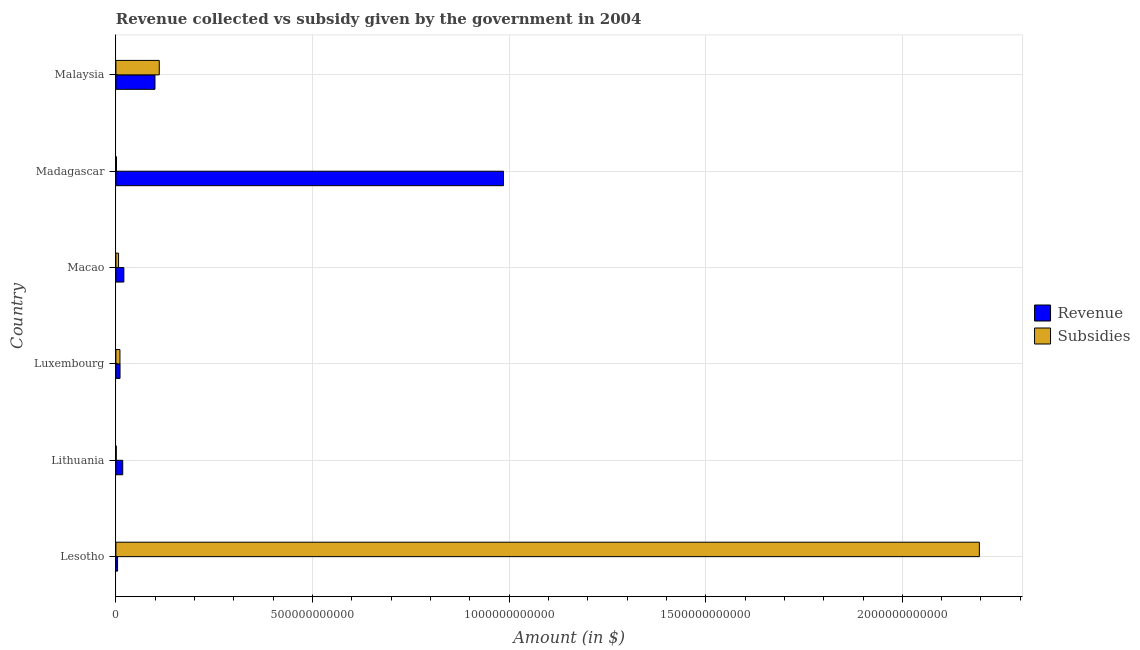Are the number of bars on each tick of the Y-axis equal?
Your answer should be compact. Yes. How many bars are there on the 2nd tick from the top?
Offer a terse response. 2. What is the label of the 3rd group of bars from the top?
Provide a short and direct response. Macao. What is the amount of revenue collected in Malaysia?
Keep it short and to the point. 9.94e+1. Across all countries, what is the maximum amount of subsidies given?
Offer a very short reply. 2.20e+12. Across all countries, what is the minimum amount of revenue collected?
Provide a short and direct response. 4.25e+09. In which country was the amount of revenue collected maximum?
Offer a very short reply. Madagascar. In which country was the amount of subsidies given minimum?
Provide a succinct answer. Lithuania. What is the total amount of revenue collected in the graph?
Your answer should be very brief. 1.14e+12. What is the difference between the amount of revenue collected in Lesotho and that in Madagascar?
Offer a very short reply. -9.81e+11. What is the difference between the amount of subsidies given in Luxembourg and the amount of revenue collected in Macao?
Your answer should be compact. -9.94e+09. What is the average amount of revenue collected per country?
Keep it short and to the point. 1.90e+11. What is the difference between the amount of subsidies given and amount of revenue collected in Malaysia?
Your response must be concise. 1.09e+1. What is the ratio of the amount of subsidies given in Lithuania to that in Malaysia?
Offer a terse response. 0.01. Is the amount of revenue collected in Lesotho less than that in Malaysia?
Your response must be concise. Yes. Is the difference between the amount of revenue collected in Lithuania and Madagascar greater than the difference between the amount of subsidies given in Lithuania and Madagascar?
Your response must be concise. No. What is the difference between the highest and the second highest amount of subsidies given?
Your response must be concise. 2.09e+12. What is the difference between the highest and the lowest amount of subsidies given?
Your response must be concise. 2.20e+12. In how many countries, is the amount of revenue collected greater than the average amount of revenue collected taken over all countries?
Give a very brief answer. 1. What does the 1st bar from the top in Lithuania represents?
Provide a short and direct response. Subsidies. What does the 1st bar from the bottom in Lithuania represents?
Provide a short and direct response. Revenue. How many countries are there in the graph?
Your answer should be compact. 6. What is the difference between two consecutive major ticks on the X-axis?
Your answer should be very brief. 5.00e+11. Does the graph contain grids?
Give a very brief answer. Yes. How are the legend labels stacked?
Your response must be concise. Vertical. What is the title of the graph?
Your answer should be compact. Revenue collected vs subsidy given by the government in 2004. Does "Urban" appear as one of the legend labels in the graph?
Provide a succinct answer. No. What is the label or title of the X-axis?
Offer a terse response. Amount (in $). What is the Amount (in $) of Revenue in Lesotho?
Your answer should be compact. 4.25e+09. What is the Amount (in $) of Subsidies in Lesotho?
Your answer should be compact. 2.20e+12. What is the Amount (in $) of Revenue in Lithuania?
Your response must be concise. 1.74e+1. What is the Amount (in $) of Subsidies in Lithuania?
Offer a terse response. 8.99e+08. What is the Amount (in $) of Revenue in Luxembourg?
Offer a terse response. 1.05e+1. What is the Amount (in $) in Subsidies in Luxembourg?
Your answer should be compact. 1.03e+1. What is the Amount (in $) in Revenue in Macao?
Provide a short and direct response. 2.02e+1. What is the Amount (in $) in Subsidies in Macao?
Make the answer very short. 6.78e+09. What is the Amount (in $) of Revenue in Madagascar?
Your answer should be compact. 9.86e+11. What is the Amount (in $) of Subsidies in Madagascar?
Offer a very short reply. 1.49e+09. What is the Amount (in $) in Revenue in Malaysia?
Provide a short and direct response. 9.94e+1. What is the Amount (in $) in Subsidies in Malaysia?
Make the answer very short. 1.10e+11. Across all countries, what is the maximum Amount (in $) of Revenue?
Keep it short and to the point. 9.86e+11. Across all countries, what is the maximum Amount (in $) of Subsidies?
Give a very brief answer. 2.20e+12. Across all countries, what is the minimum Amount (in $) of Revenue?
Keep it short and to the point. 4.25e+09. Across all countries, what is the minimum Amount (in $) of Subsidies?
Give a very brief answer. 8.99e+08. What is the total Amount (in $) in Revenue in the graph?
Provide a short and direct response. 1.14e+12. What is the total Amount (in $) in Subsidies in the graph?
Your response must be concise. 2.33e+12. What is the difference between the Amount (in $) in Revenue in Lesotho and that in Lithuania?
Your response must be concise. -1.31e+1. What is the difference between the Amount (in $) in Subsidies in Lesotho and that in Lithuania?
Offer a very short reply. 2.20e+12. What is the difference between the Amount (in $) of Revenue in Lesotho and that in Luxembourg?
Make the answer very short. -6.28e+09. What is the difference between the Amount (in $) in Subsidies in Lesotho and that in Luxembourg?
Provide a succinct answer. 2.19e+12. What is the difference between the Amount (in $) of Revenue in Lesotho and that in Macao?
Provide a succinct answer. -1.60e+1. What is the difference between the Amount (in $) in Subsidies in Lesotho and that in Macao?
Your answer should be compact. 2.19e+12. What is the difference between the Amount (in $) of Revenue in Lesotho and that in Madagascar?
Your answer should be compact. -9.81e+11. What is the difference between the Amount (in $) of Subsidies in Lesotho and that in Madagascar?
Your answer should be very brief. 2.19e+12. What is the difference between the Amount (in $) of Revenue in Lesotho and that in Malaysia?
Provide a succinct answer. -9.51e+1. What is the difference between the Amount (in $) of Subsidies in Lesotho and that in Malaysia?
Give a very brief answer. 2.09e+12. What is the difference between the Amount (in $) in Revenue in Lithuania and that in Luxembourg?
Offer a terse response. 6.87e+09. What is the difference between the Amount (in $) in Subsidies in Lithuania and that in Luxembourg?
Provide a short and direct response. -9.41e+09. What is the difference between the Amount (in $) of Revenue in Lithuania and that in Macao?
Ensure brevity in your answer.  -2.85e+09. What is the difference between the Amount (in $) of Subsidies in Lithuania and that in Macao?
Ensure brevity in your answer.  -5.88e+09. What is the difference between the Amount (in $) of Revenue in Lithuania and that in Madagascar?
Give a very brief answer. -9.68e+11. What is the difference between the Amount (in $) in Subsidies in Lithuania and that in Madagascar?
Give a very brief answer. -5.91e+08. What is the difference between the Amount (in $) in Revenue in Lithuania and that in Malaysia?
Keep it short and to the point. -8.20e+1. What is the difference between the Amount (in $) in Subsidies in Lithuania and that in Malaysia?
Your answer should be very brief. -1.09e+11. What is the difference between the Amount (in $) in Revenue in Luxembourg and that in Macao?
Your response must be concise. -9.72e+09. What is the difference between the Amount (in $) in Subsidies in Luxembourg and that in Macao?
Offer a terse response. 3.53e+09. What is the difference between the Amount (in $) of Revenue in Luxembourg and that in Madagascar?
Offer a terse response. -9.75e+11. What is the difference between the Amount (in $) of Subsidies in Luxembourg and that in Madagascar?
Ensure brevity in your answer.  8.82e+09. What is the difference between the Amount (in $) of Revenue in Luxembourg and that in Malaysia?
Offer a terse response. -8.89e+1. What is the difference between the Amount (in $) in Subsidies in Luxembourg and that in Malaysia?
Keep it short and to the point. -1.00e+11. What is the difference between the Amount (in $) in Revenue in Macao and that in Madagascar?
Your response must be concise. -9.65e+11. What is the difference between the Amount (in $) in Subsidies in Macao and that in Madagascar?
Offer a very short reply. 5.29e+09. What is the difference between the Amount (in $) of Revenue in Macao and that in Malaysia?
Provide a short and direct response. -7.91e+1. What is the difference between the Amount (in $) in Subsidies in Macao and that in Malaysia?
Make the answer very short. -1.04e+11. What is the difference between the Amount (in $) in Revenue in Madagascar and that in Malaysia?
Your answer should be compact. 8.86e+11. What is the difference between the Amount (in $) in Subsidies in Madagascar and that in Malaysia?
Ensure brevity in your answer.  -1.09e+11. What is the difference between the Amount (in $) in Revenue in Lesotho and the Amount (in $) in Subsidies in Lithuania?
Your answer should be very brief. 3.35e+09. What is the difference between the Amount (in $) in Revenue in Lesotho and the Amount (in $) in Subsidies in Luxembourg?
Provide a succinct answer. -6.06e+09. What is the difference between the Amount (in $) of Revenue in Lesotho and the Amount (in $) of Subsidies in Macao?
Your response must be concise. -2.53e+09. What is the difference between the Amount (in $) of Revenue in Lesotho and the Amount (in $) of Subsidies in Madagascar?
Your response must be concise. 2.76e+09. What is the difference between the Amount (in $) of Revenue in Lesotho and the Amount (in $) of Subsidies in Malaysia?
Ensure brevity in your answer.  -1.06e+11. What is the difference between the Amount (in $) of Revenue in Lithuania and the Amount (in $) of Subsidies in Luxembourg?
Provide a succinct answer. 7.09e+09. What is the difference between the Amount (in $) of Revenue in Lithuania and the Amount (in $) of Subsidies in Macao?
Your response must be concise. 1.06e+1. What is the difference between the Amount (in $) of Revenue in Lithuania and the Amount (in $) of Subsidies in Madagascar?
Provide a succinct answer. 1.59e+1. What is the difference between the Amount (in $) in Revenue in Lithuania and the Amount (in $) in Subsidies in Malaysia?
Offer a terse response. -9.29e+1. What is the difference between the Amount (in $) in Revenue in Luxembourg and the Amount (in $) in Subsidies in Macao?
Give a very brief answer. 3.75e+09. What is the difference between the Amount (in $) of Revenue in Luxembourg and the Amount (in $) of Subsidies in Madagascar?
Offer a very short reply. 9.04e+09. What is the difference between the Amount (in $) in Revenue in Luxembourg and the Amount (in $) in Subsidies in Malaysia?
Make the answer very short. -9.98e+1. What is the difference between the Amount (in $) in Revenue in Macao and the Amount (in $) in Subsidies in Madagascar?
Keep it short and to the point. 1.88e+1. What is the difference between the Amount (in $) in Revenue in Macao and the Amount (in $) in Subsidies in Malaysia?
Your response must be concise. -9.01e+1. What is the difference between the Amount (in $) of Revenue in Madagascar and the Amount (in $) of Subsidies in Malaysia?
Offer a terse response. 8.75e+11. What is the average Amount (in $) in Revenue per country?
Your answer should be very brief. 1.90e+11. What is the average Amount (in $) of Subsidies per country?
Your answer should be compact. 3.88e+11. What is the difference between the Amount (in $) of Revenue and Amount (in $) of Subsidies in Lesotho?
Ensure brevity in your answer.  -2.19e+12. What is the difference between the Amount (in $) in Revenue and Amount (in $) in Subsidies in Lithuania?
Make the answer very short. 1.65e+1. What is the difference between the Amount (in $) of Revenue and Amount (in $) of Subsidies in Luxembourg?
Ensure brevity in your answer.  2.16e+08. What is the difference between the Amount (in $) of Revenue and Amount (in $) of Subsidies in Macao?
Give a very brief answer. 1.35e+1. What is the difference between the Amount (in $) of Revenue and Amount (in $) of Subsidies in Madagascar?
Offer a very short reply. 9.84e+11. What is the difference between the Amount (in $) in Revenue and Amount (in $) in Subsidies in Malaysia?
Ensure brevity in your answer.  -1.09e+1. What is the ratio of the Amount (in $) in Revenue in Lesotho to that in Lithuania?
Your answer should be compact. 0.24. What is the ratio of the Amount (in $) of Subsidies in Lesotho to that in Lithuania?
Provide a succinct answer. 2442.01. What is the ratio of the Amount (in $) of Revenue in Lesotho to that in Luxembourg?
Make the answer very short. 0.4. What is the ratio of the Amount (in $) in Subsidies in Lesotho to that in Luxembourg?
Your response must be concise. 212.94. What is the ratio of the Amount (in $) in Revenue in Lesotho to that in Macao?
Your answer should be very brief. 0.21. What is the ratio of the Amount (in $) in Subsidies in Lesotho to that in Macao?
Provide a succinct answer. 323.85. What is the ratio of the Amount (in $) of Revenue in Lesotho to that in Madagascar?
Your answer should be very brief. 0. What is the ratio of the Amount (in $) in Subsidies in Lesotho to that in Madagascar?
Your answer should be compact. 1473.38. What is the ratio of the Amount (in $) of Revenue in Lesotho to that in Malaysia?
Give a very brief answer. 0.04. What is the ratio of the Amount (in $) in Subsidies in Lesotho to that in Malaysia?
Keep it short and to the point. 19.9. What is the ratio of the Amount (in $) of Revenue in Lithuania to that in Luxembourg?
Offer a very short reply. 1.65. What is the ratio of the Amount (in $) in Subsidies in Lithuania to that in Luxembourg?
Your answer should be very brief. 0.09. What is the ratio of the Amount (in $) in Revenue in Lithuania to that in Macao?
Offer a very short reply. 0.86. What is the ratio of the Amount (in $) in Subsidies in Lithuania to that in Macao?
Offer a terse response. 0.13. What is the ratio of the Amount (in $) in Revenue in Lithuania to that in Madagascar?
Offer a very short reply. 0.02. What is the ratio of the Amount (in $) in Subsidies in Lithuania to that in Madagascar?
Keep it short and to the point. 0.6. What is the ratio of the Amount (in $) in Revenue in Lithuania to that in Malaysia?
Provide a short and direct response. 0.18. What is the ratio of the Amount (in $) of Subsidies in Lithuania to that in Malaysia?
Your response must be concise. 0.01. What is the ratio of the Amount (in $) in Revenue in Luxembourg to that in Macao?
Ensure brevity in your answer.  0.52. What is the ratio of the Amount (in $) of Subsidies in Luxembourg to that in Macao?
Your answer should be very brief. 1.52. What is the ratio of the Amount (in $) in Revenue in Luxembourg to that in Madagascar?
Keep it short and to the point. 0.01. What is the ratio of the Amount (in $) of Subsidies in Luxembourg to that in Madagascar?
Ensure brevity in your answer.  6.92. What is the ratio of the Amount (in $) in Revenue in Luxembourg to that in Malaysia?
Keep it short and to the point. 0.11. What is the ratio of the Amount (in $) of Subsidies in Luxembourg to that in Malaysia?
Your answer should be very brief. 0.09. What is the ratio of the Amount (in $) in Revenue in Macao to that in Madagascar?
Your answer should be very brief. 0.02. What is the ratio of the Amount (in $) of Subsidies in Macao to that in Madagascar?
Provide a succinct answer. 4.55. What is the ratio of the Amount (in $) in Revenue in Macao to that in Malaysia?
Give a very brief answer. 0.2. What is the ratio of the Amount (in $) in Subsidies in Macao to that in Malaysia?
Provide a short and direct response. 0.06. What is the ratio of the Amount (in $) in Revenue in Madagascar to that in Malaysia?
Offer a very short reply. 9.92. What is the ratio of the Amount (in $) of Subsidies in Madagascar to that in Malaysia?
Make the answer very short. 0.01. What is the difference between the highest and the second highest Amount (in $) in Revenue?
Provide a short and direct response. 8.86e+11. What is the difference between the highest and the second highest Amount (in $) in Subsidies?
Give a very brief answer. 2.09e+12. What is the difference between the highest and the lowest Amount (in $) of Revenue?
Provide a succinct answer. 9.81e+11. What is the difference between the highest and the lowest Amount (in $) of Subsidies?
Make the answer very short. 2.20e+12. 